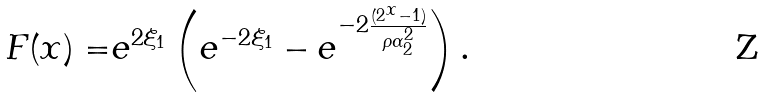Convert formula to latex. <formula><loc_0><loc_0><loc_500><loc_500>F ( x ) = & e ^ { 2 \xi _ { 1 } } \left ( e ^ { - 2 \xi _ { 1 } } - e ^ { - 2 \frac { ( 2 ^ { x } - 1 ) } { \rho \alpha _ { 2 } ^ { 2 } } } \right ) .</formula> 